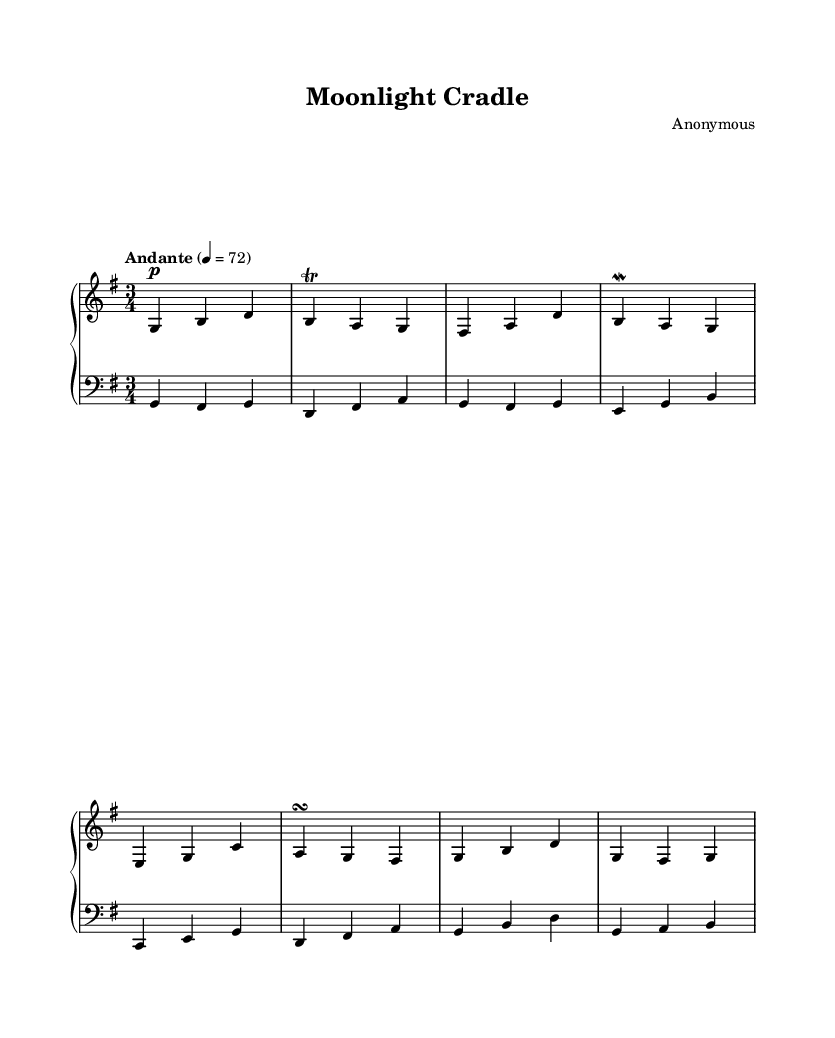What is the key signature of this music? The key signature indicates one sharp (F#) and is thus G major. This can be determined by looking at the key signature shown at the beginning of the sheet music.
Answer: G major What is the time signature of this music? The time signature is indicated at the beginning of the piece and is shown as 3/4. This means there are three beats in each measure and a quarter note gets one beat.
Answer: 3/4 What is the tempo marking of this piece? The tempo marking is given under the global section, stating "Andante" with a metronomic marking of 4 = 72. This indicates a moderately slow tempo.
Answer: Andante 4 = 72 How many measures are present in the harpsichord part? By counting the measure bars in the harpsichord line, there are a total of eight measures. This can be verified by identifying the individual segments separated by vertical bar lines in the notation.
Answer: 8 What is the dynamic marking for the harpsichord? The dynamic marking is indicated as 'p', which stands for 'piano' meaning soft. This marking informs the performer to play this section softly.
Answer: p What ornamentation is used in the harpsichord part? The harpsichord part contains a trill (denoted by the abbreviation "tr") on the note b, and a mordent (denoted by "mordent") on the note a. These are common decorations of Baroque music and indicate specific playing techniques.
Answer: Trill and mordent What role does the viola play in relation to the harpsichord? The viola plays a harmonic role, providing a bass line and supporting chords in conjunction with the harpsichord, which is typical in Baroque compositions, where instruments often accompany one another.
Answer: Harmonic support 